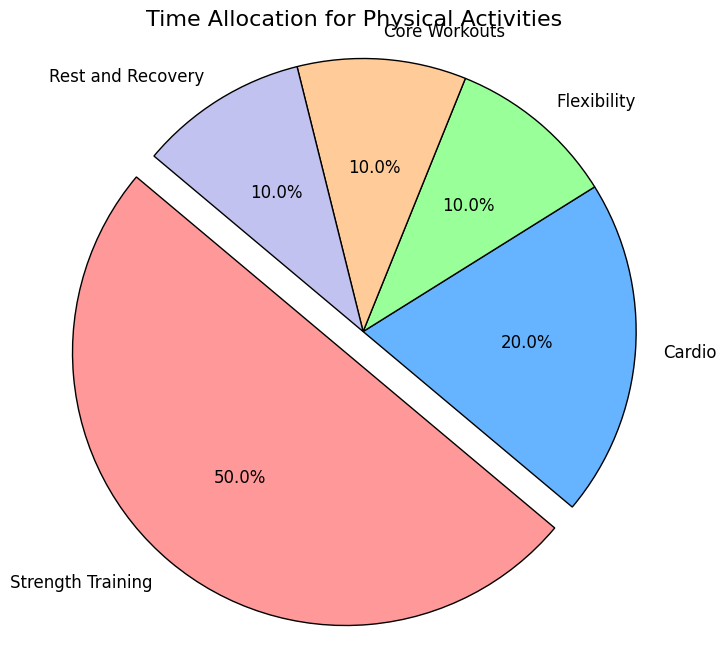What activity occupies half of the time allocation? According to the pie chart, the activity occupying half of the time allocation is shown with 50% mentioned as "Strength Training."
Answer: Strength Training How much more time is spent on Strength Training compared to Cardio? Strength Training is 50% while Cardio is 20%. The difference is 50% - 20% = 30%.
Answer: 30% Which activity is assigned the smallest portion of time? The smallest portions of time, each with 10%, are Flexibility, Core Workouts, and Rest and Recovery. However, they are all equal, so all can be considered.
Answer: Flexibility, Core Workouts, Rest and Recovery What is the combined percentage of time spent on activities other than Strength Training? Strength Training is 50%, so the rest is 100% - 50% = 50%.
Answer: 50% Is Core Workouts allocated a greater percentage of time than Flexibility? The pie chart shows both Core Workouts and Flexibility are allocated the same percentage of time, 10%.
Answer: No Which segment is "exploded" in the chart, and what color is it? The exploded segment is for Strength Training, and it is in red.
Answer: Strength Training, red What percentage of time is allocated for activities other than Strength Training and Cardio combined? Strength Training is 50% and Cardio is 20%. Summing these is 50% + 20% = 70%. The remaining is 100% - 70% = 30%.
Answer: 30% How much more time is spent on Strength Training compared to Flexibility, Core Workouts, and Rest and Recovery combined? Strength Training is 50%, and Flexibility, Core Workouts, and Rest and Recovery are each 10%. Combined, they are 10% + 10% + 10% = 30%. The difference is 50% - 30% = 20%.
Answer: 20% What is the total percentage of time allocated for activities grouped under 10%? Flexibility, Core Workouts, and Rest and Recovery each have 10%. Summing these gives 10% + 10% + 10% = 30%.
Answer: 30% Which activity is shown in blue, and what percentage of time is allocated to it? Cardio is shown in blue and it is allocated 20% of the time.
Answer: Cardio, 20% 